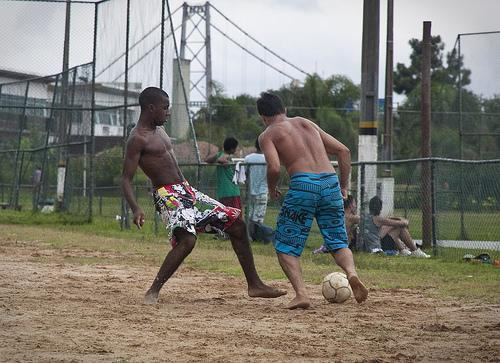Estimate the height of the grey suspension bridge mentioned in the image. The grey suspension bridge has a height of 241 units. Identify the color and position of the shorts worn by the man in the light blue shirt. The man in the light blue shirt is standing next to the man in the green shirt, and he is wearing red shorts. Provide a brief description of the shirtless man's attire. The shirtless man is black, wearing colorful shorts with a snake logo, and sitting against a fence. Count the total number of people mentioned in the given information. There are seven people mentioned in the information. Mention the color and type of the fence present in the image. The fence is black and made of chainlink material. Characterize the condition of the soccer ball and the playing field. The soccer ball is dirty and white while the playing field has muddy dirt and footprints. How many people are directly involved with the white soccer ball? Two young men are directly involved with the white soccer ball. What is the distinguishing feature of the girl sitting near the fence? The girl sitting near the fence has a ponytail and is wearing white sneakers. What game is being played in the image? Soccer is being played in the image. What color is the shirt of the man lifting his foot? The man is shirtless. Explain the sentiment of the people playing soccer. The people are happy and engaged.  What kind of shoes is the girl with the ponytail wearing? White sneakers. Read any text present in the image. No text present in the image. Spot the red car parked near the soccer field. This instruction is misleading because none of the captions mention a red car or any vehicle related to the image. It's not mentioned in the image's context, leading the viewer to search for a non-existent object. Find any anomalies present in the image. No anomalies detected. What is the interaction between the people, the fence, and the soccer ball? People are playing soccer near a black chain link fence. Rate the quality of the image from a scale from 1 to 5. 3 Which caption correctly describes the state of the soccer ball? B. The soccer ball is dirty. Could you please find the large pink elephant in the image? This instruction is misleading because there is no mention of a pink elephant in any caption, and it is very unlikely that an elephant would appear in a context involving soccer. Identify the two elements on the bridge. Grey suspension bridge and the top of the suspension bridge. Can you point out the spacecraft hovering over the field? This instruction is misleading because there is no mention of a spacecraft in any of the captions. Additionally, it's not likely to find a spacecraft in a simple soccer game context, making the viewer search for an object that doesn't exist in the image. What color is the backpack on the ground? The backpack is blue. What can you infer from the image about the playing field's condition? The playing field is muddy with footprints in the dirt. Link the mention of the snake logo to its corresponding object in the image. The snake logo is on the blue shorts. Point out the color of the short that the boy is wearing. The short is blue. Locate the banana that the soccer players are using instead of a ball. This instruction is misleading as it is directly contradicting several captions mentioning a white soccer ball, and there is no mention or indication of a banana being used instead of a soccer ball. Describe the shirt of the man wearing red shorts. The man is wearing a green shirt. Notice how the rainbow unicorn is interrupting the soccer game. This instruction is misleading since there are no mentions of a rainbow unicorn in any of the captions, and it's also improbable for a mythical creature like a unicorn to be present in a realistic scenario like a soccer game. Identify the woman wearing a purple hat and dancing in the field. This instruction is misleading because there is no mention of a woman wearing a purple hat or dancing in the field in any of the given captions. The scene is focusing on soccer, not dancing, so it's unlikely that such a character would appear. Does the fence in the image have any unique features? Yes, the fence is a green chainlink and black chained fence. Describe the color and state of the soccer ball. The soccer ball is white and dirty. How many young men are playing with the soccer ball? Two young men are playing with the soccer ball. Is the bridge in the image small or tall? The bridge is tall. 